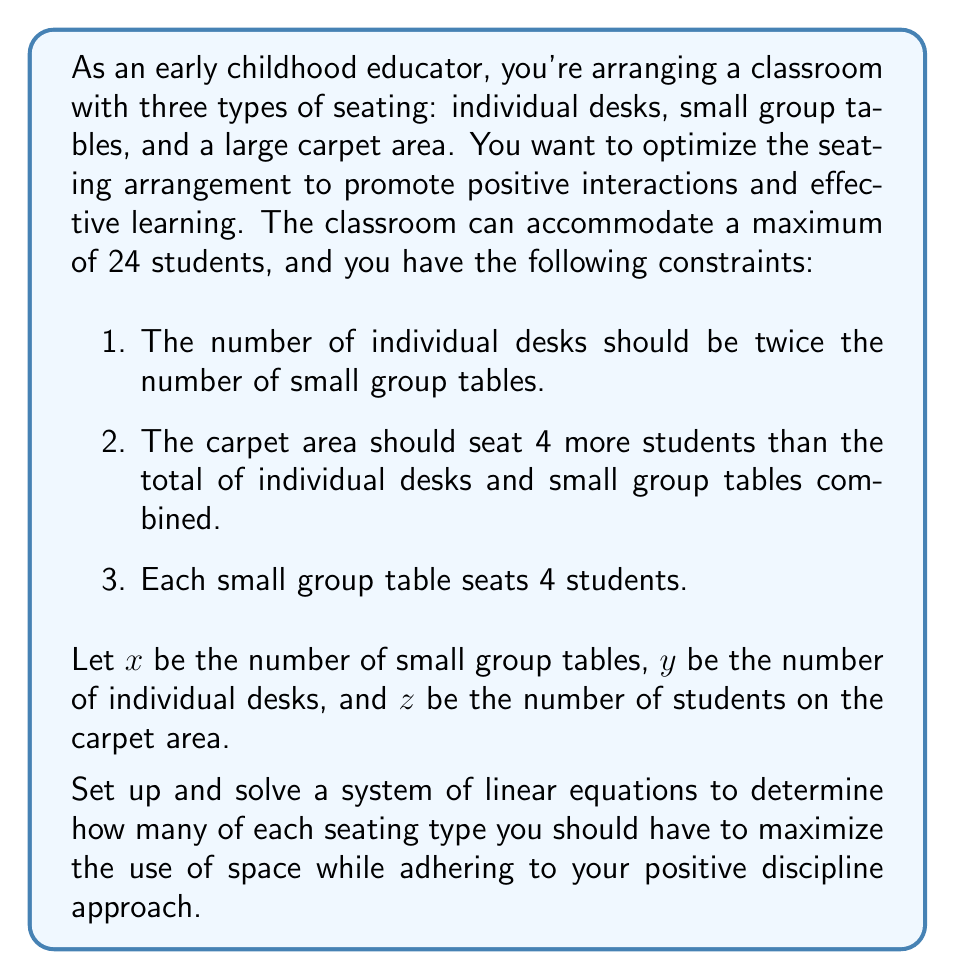Could you help me with this problem? Let's approach this step-by-step:

1) First, we'll set up our system of equations based on the given information:

   Equation 1: $y = 2x$ (number of desks is twice the number of tables)
   Equation 2: $z = (x + y) + 4$ (carpet area seats 4 more than tables and desks combined)
   Equation 3: $4x + y + z = 24$ (total number of students is 24)

2) We can substitute Equation 1 into Equations 2 and 3:

   Equation 2: $z = (x + 2x) + 4 = 3x + 4$
   Equation 3: $4x + 2x + z = 24$

3) Now substitute the new Equation 2 into Equation 3:

   $4x + 2x + (3x + 4) = 24$
   $9x + 4 = 24$

4) Solve for x:

   $9x = 20$
   $x = \frac{20}{9} \approx 2.22$

5) Since we can't have a fractional number of tables, we round down to 2 tables.

6) Now we can solve for y and z:

   $y = 2x = 2(2) = 4$ individual desks
   $z = 3x + 4 = 3(2) + 4 = 10$ students on the carpet

7) Let's verify our solution:
   - 2 small group tables seating 4 students each: $2 * 4 = 8$ students
   - 4 individual desks: 4 students
   - 10 students on the carpet
   Total: $8 + 4 + 10 = 22$ students (which is within our maximum of 24)

This arrangement provides a good balance of individual work spaces, small group collaboration areas, and a large group gathering space, which aligns well with positive discipline approaches in early childhood education.
Answer: The optimal seating arrangement is:
- 2 small group tables
- 4 individual desks
- Carpet area for 10 students 